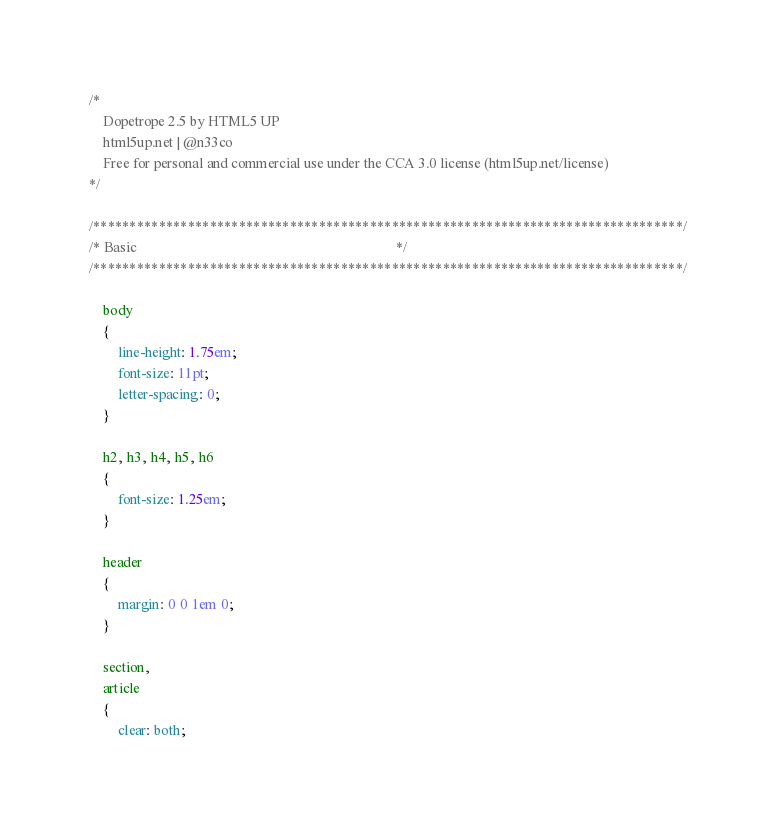<code> <loc_0><loc_0><loc_500><loc_500><_CSS_>/*
	Dopetrope 2.5 by HTML5 UP
	html5up.net | @n33co
	Free for personal and commercial use under the CCA 3.0 license (html5up.net/license)
*/

/*********************************************************************************/
/* Basic                                                                         */
/*********************************************************************************/

	body
	{
		line-height: 1.75em;
		font-size: 11pt;
		letter-spacing: 0;
	}

	h2, h3, h4, h5, h6
	{
		font-size: 1.25em;
	}

	header
	{
		margin: 0 0 1em 0;
	}

	section,
	article
	{
		clear: both;</code> 